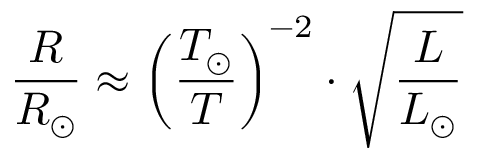Convert formula to latex. <formula><loc_0><loc_0><loc_500><loc_500>{ \frac { R } { R _ { \odot } } } \approx \left ( { \frac { T _ { \odot } } { T } } \right ) ^ { - 2 } \cdot { \sqrt { \frac { L } { L _ { \odot } } } }</formula> 